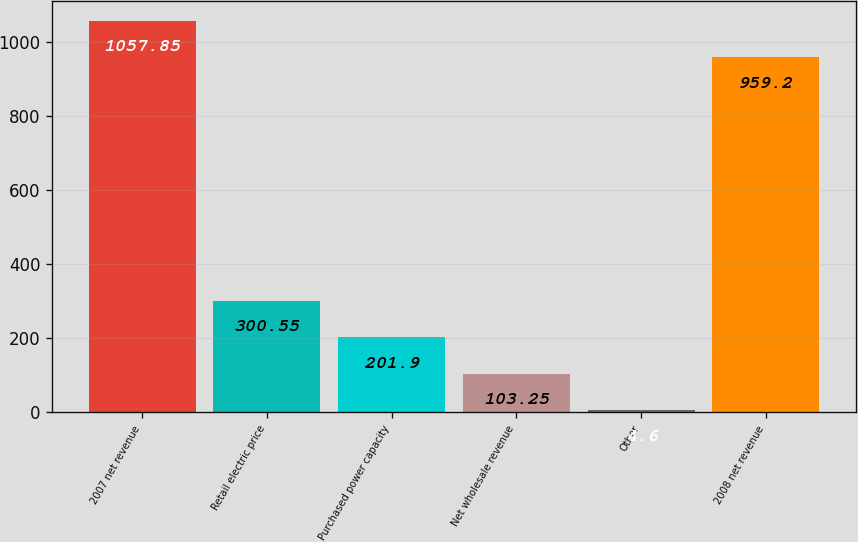Convert chart. <chart><loc_0><loc_0><loc_500><loc_500><bar_chart><fcel>2007 net revenue<fcel>Retail electric price<fcel>Purchased power capacity<fcel>Net wholesale revenue<fcel>Other<fcel>2008 net revenue<nl><fcel>1057.85<fcel>300.55<fcel>201.9<fcel>103.25<fcel>4.6<fcel>959.2<nl></chart> 